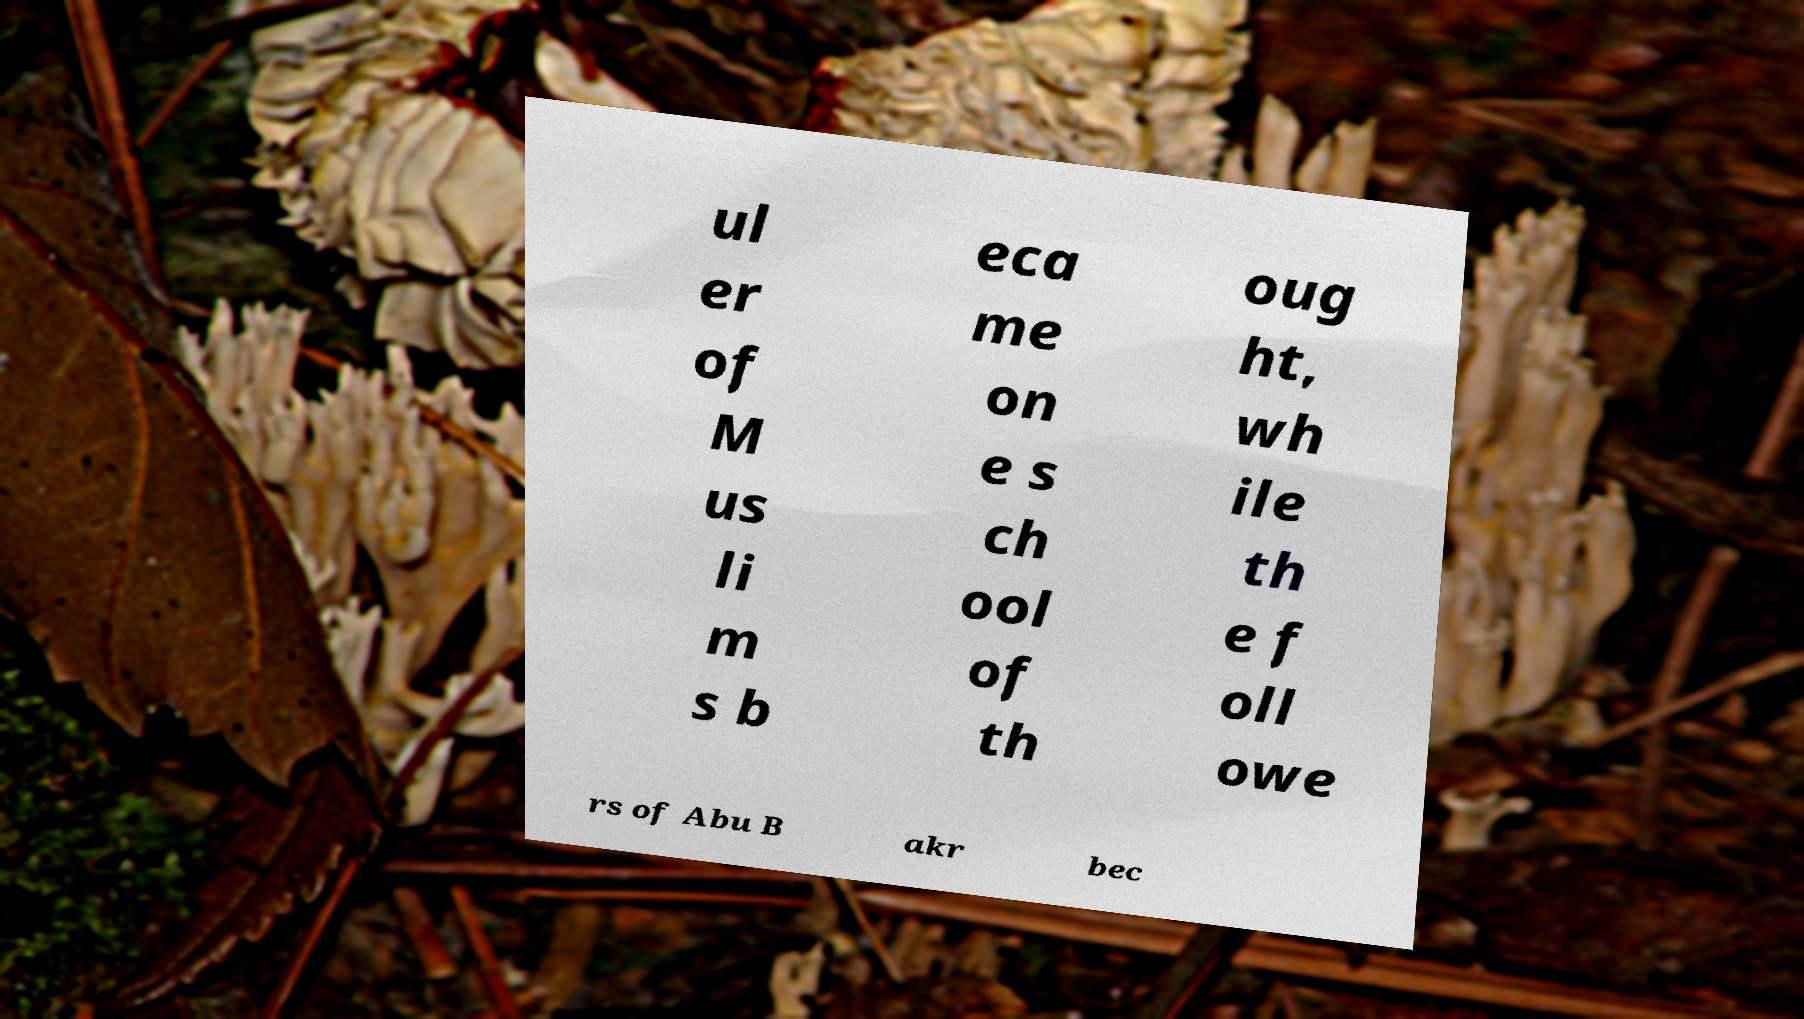There's text embedded in this image that I need extracted. Can you transcribe it verbatim? ul er of M us li m s b eca me on e s ch ool of th oug ht, wh ile th e f oll owe rs of Abu B akr bec 